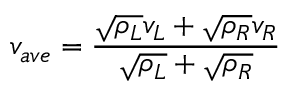Convert formula to latex. <formula><loc_0><loc_0><loc_500><loc_500>v _ { a v e } = \frac { \sqrt { \rho _ { L } } v _ { L } + \sqrt { \rho _ { R } } v _ { R } } { \sqrt { \rho _ { L } } + \sqrt { \rho _ { R } } }</formula> 